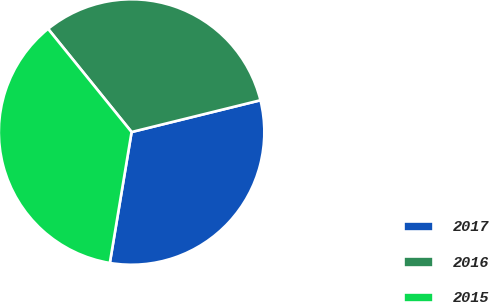Convert chart. <chart><loc_0><loc_0><loc_500><loc_500><pie_chart><fcel>2017<fcel>2016<fcel>2015<nl><fcel>31.47%<fcel>31.98%<fcel>36.55%<nl></chart> 